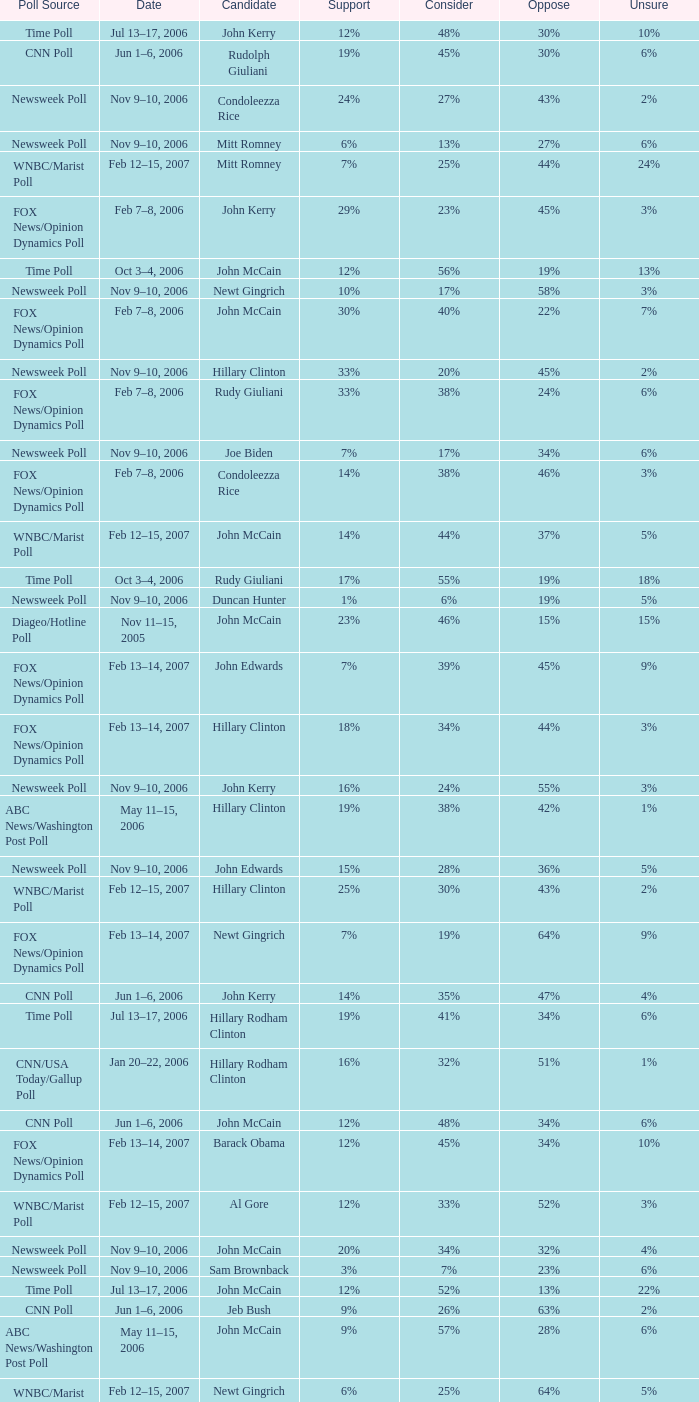Can you give me this table as a dict? {'header': ['Poll Source', 'Date', 'Candidate', 'Support', 'Consider', 'Oppose', 'Unsure'], 'rows': [['Time Poll', 'Jul 13–17, 2006', 'John Kerry', '12%', '48%', '30%', '10%'], ['CNN Poll', 'Jun 1–6, 2006', 'Rudolph Giuliani', '19%', '45%', '30%', '6%'], ['Newsweek Poll', 'Nov 9–10, 2006', 'Condoleezza Rice', '24%', '27%', '43%', '2%'], ['Newsweek Poll', 'Nov 9–10, 2006', 'Mitt Romney', '6%', '13%', '27%', '6%'], ['WNBC/Marist Poll', 'Feb 12–15, 2007', 'Mitt Romney', '7%', '25%', '44%', '24%'], ['FOX News/Opinion Dynamics Poll', 'Feb 7–8, 2006', 'John Kerry', '29%', '23%', '45%', '3%'], ['Time Poll', 'Oct 3–4, 2006', 'John McCain', '12%', '56%', '19%', '13%'], ['Newsweek Poll', 'Nov 9–10, 2006', 'Newt Gingrich', '10%', '17%', '58%', '3%'], ['FOX News/Opinion Dynamics Poll', 'Feb 7–8, 2006', 'John McCain', '30%', '40%', '22%', '7%'], ['Newsweek Poll', 'Nov 9–10, 2006', 'Hillary Clinton', '33%', '20%', '45%', '2%'], ['FOX News/Opinion Dynamics Poll', 'Feb 7–8, 2006', 'Rudy Giuliani', '33%', '38%', '24%', '6%'], ['Newsweek Poll', 'Nov 9–10, 2006', 'Joe Biden', '7%', '17%', '34%', '6%'], ['FOX News/Opinion Dynamics Poll', 'Feb 7–8, 2006', 'Condoleezza Rice', '14%', '38%', '46%', '3%'], ['WNBC/Marist Poll', 'Feb 12–15, 2007', 'John McCain', '14%', '44%', '37%', '5%'], ['Time Poll', 'Oct 3–4, 2006', 'Rudy Giuliani', '17%', '55%', '19%', '18%'], ['Newsweek Poll', 'Nov 9–10, 2006', 'Duncan Hunter', '1%', '6%', '19%', '5%'], ['Diageo/Hotline Poll', 'Nov 11–15, 2005', 'John McCain', '23%', '46%', '15%', '15%'], ['FOX News/Opinion Dynamics Poll', 'Feb 13–14, 2007', 'John Edwards', '7%', '39%', '45%', '9%'], ['FOX News/Opinion Dynamics Poll', 'Feb 13–14, 2007', 'Hillary Clinton', '18%', '34%', '44%', '3%'], ['Newsweek Poll', 'Nov 9–10, 2006', 'John Kerry', '16%', '24%', '55%', '3%'], ['ABC News/Washington Post Poll', 'May 11–15, 2006', 'Hillary Clinton', '19%', '38%', '42%', '1%'], ['Newsweek Poll', 'Nov 9–10, 2006', 'John Edwards', '15%', '28%', '36%', '5%'], ['WNBC/Marist Poll', 'Feb 12–15, 2007', 'Hillary Clinton', '25%', '30%', '43%', '2%'], ['FOX News/Opinion Dynamics Poll', 'Feb 13–14, 2007', 'Newt Gingrich', '7%', '19%', '64%', '9%'], ['CNN Poll', 'Jun 1–6, 2006', 'John Kerry', '14%', '35%', '47%', '4%'], ['Time Poll', 'Jul 13–17, 2006', 'Hillary Rodham Clinton', '19%', '41%', '34%', '6%'], ['CNN/USA Today/Gallup Poll', 'Jan 20–22, 2006', 'Hillary Rodham Clinton', '16%', '32%', '51%', '1%'], ['CNN Poll', 'Jun 1–6, 2006', 'John McCain', '12%', '48%', '34%', '6%'], ['FOX News/Opinion Dynamics Poll', 'Feb 13–14, 2007', 'Barack Obama', '12%', '45%', '34%', '10%'], ['WNBC/Marist Poll', 'Feb 12–15, 2007', 'Al Gore', '12%', '33%', '52%', '3%'], ['Newsweek Poll', 'Nov 9–10, 2006', 'John McCain', '20%', '34%', '32%', '4%'], ['Newsweek Poll', 'Nov 9–10, 2006', 'Sam Brownback', '3%', '7%', '23%', '6%'], ['Time Poll', 'Jul 13–17, 2006', 'John McCain', '12%', '52%', '13%', '22%'], ['CNN Poll', 'Jun 1–6, 2006', 'Jeb Bush', '9%', '26%', '63%', '2%'], ['ABC News/Washington Post Poll', 'May 11–15, 2006', 'John McCain', '9%', '57%', '28%', '6%'], ['WNBC/Marist Poll', 'Feb 12–15, 2007', 'Newt Gingrich', '6%', '25%', '64%', '5%'], ['CNN Poll', 'Jun 1–6, 2006', 'Hillary Rodham Clinton', '22%', '28%', '47%', '3%'], ['FOX News/Opinion Dynamics Poll', 'Feb 13–14, 2007', 'Rudy Giuliani', '15%', '44%', '36%', '5%'], ['Newsweek Poll', 'Nov 9–10, 2006', 'Rudy Giuliani', '24%', '30%', '32%', '4%'], ['Time Poll', 'Oct 3–4, 2006', 'Al Gore', '16%', '44%', '35%', '5%'], ['Newsweek Poll', 'Nov 9–10, 2006', 'Barack Obama', '20%', '19%', '24%', '3%'], ['Time Poll', 'Jul 13–17, 2006', 'Rudy Giuliani', '17%', '54%', '14%', '15%'], ['WNBC/Marist Poll', 'Feb 12–15, 2007', 'Rudy Giuliani', '16%', '51%', '30%', '3%'], ['FOX News/Opinion Dynamics Poll', 'Feb 13–14, 2007', 'Ralph Nader', '3%', '14%', '76%', '8%'], ['Time Poll', 'Jul 13–17, 2006', 'Al Gore', '16%', '45%', '32%', '7%'], ['WNBC/Marist Poll', 'Feb 12–15, 2007', 'Barack Obama', '17%', '42%', '32%', '9%'], ['CNN/USA Today/Gallup Poll', 'Jun 9–10, 2003', 'Hillary Rodham Clinton', '20%', '33%', '45%', '2%'], ['Newsweek Poll', 'Nov 9–10, 2006', 'Al Gore', '21%', '24%', '53%', '2%'], ['FOX News/Opinion Dynamics Poll', 'Feb 7–8, 2006', 'Hillary Clinton', '35%', '19%', '44%', '2%'], ['WNBC/Marist Poll', 'Feb 12–15, 2007', 'John Edwards', '12%', '45%', '35%', '8%'], ['CNN/USA Today/Gallup Poll', 'May 20–22, 2005', 'Hillary Rodham Clinton', '28%', '31%', '40%', '1%'], ['FOX News/Opinion Dynamics Poll', 'Feb 13–14, 2007', 'John McCain', '9%', '43%', '40%', '8%'], ['CNN Poll', 'Jun 1–6, 2006', 'Al Gore', '17%', '32%', '48%', '3%'], ['Time Poll', 'Oct 3–4, 2006', 'John Kerry', '14%', '43%', '34%', '9%'], ['Time Poll', 'Oct 3–4, 2006', 'Hillary Rodham Clinton', '23%', '36%', '37%', '5%']]} What percentage of people were opposed to the candidate based on the Time Poll poll that showed 6% of people were unsure? 34%. 